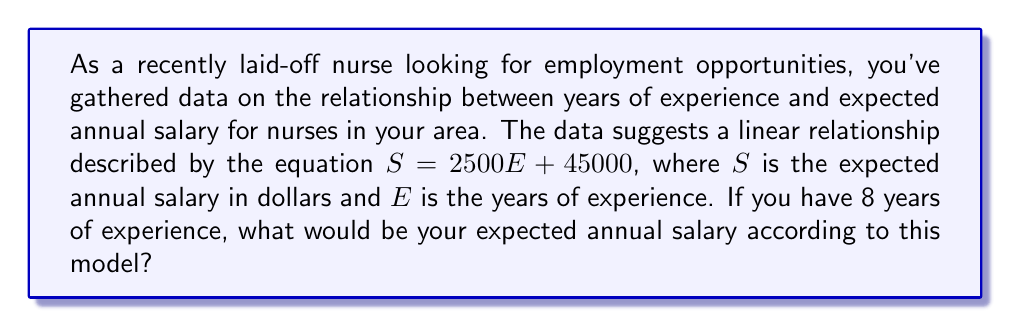Show me your answer to this math problem. To solve this problem, we need to use the given linear equation and substitute the known value for years of experience. Let's break it down step-by-step:

1. The linear equation is given as:
   $S = 2500E + 45000$

   Where:
   $S$ = Expected annual salary in dollars
   $E$ = Years of experience

2. We're told that you have 8 years of experience, so we substitute $E = 8$ into the equation:
   $S = 2500(8) + 45000$

3. Now we can solve this equation:
   $S = 20000 + 45000$
   $S = 65000$

Therefore, according to this linear model, with 8 years of experience, your expected annual salary would be $65,000.

Note: This linear relationship suggests that for each year of experience, the expected salary increases by $2,500, with a starting salary of $45,000 for no experience (when $E = 0$).
Answer: $65,000 